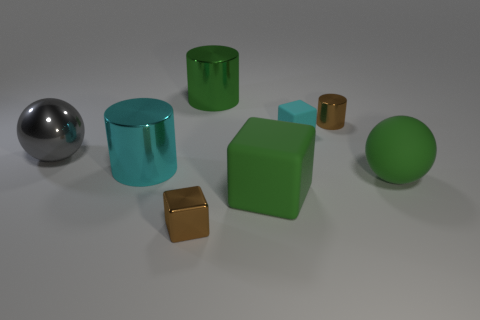Subtract all large matte blocks. How many blocks are left? 2 Add 1 brown metal cubes. How many objects exist? 9 Subtract all balls. How many objects are left? 6 Subtract 2 cubes. How many cubes are left? 1 Add 8 tiny blocks. How many tiny blocks exist? 10 Subtract 0 purple cylinders. How many objects are left? 8 Subtract all gray cylinders. Subtract all red spheres. How many cylinders are left? 3 Subtract all big metal blocks. Subtract all green balls. How many objects are left? 7 Add 7 big gray metal things. How many big gray metal things are left? 8 